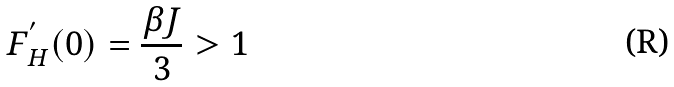<formula> <loc_0><loc_0><loc_500><loc_500>F ^ { ^ { \prime } } _ { H } ( 0 ) = \frac { \beta J } { 3 } > 1</formula> 